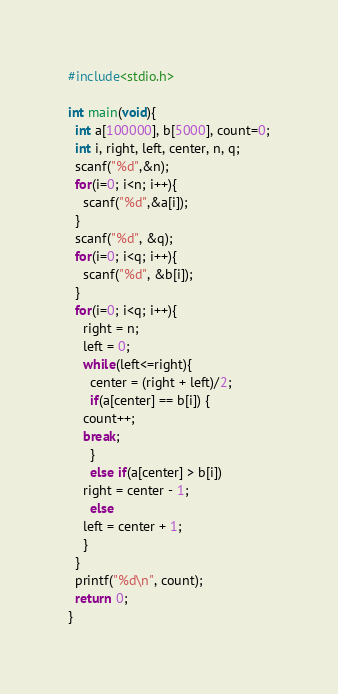<code> <loc_0><loc_0><loc_500><loc_500><_C_>#include<stdio.h>

int main(void){
  int a[100000], b[5000], count=0;
  int i, right, left, center, n, q;
  scanf("%d",&n);
  for(i=0; i<n; i++){
    scanf("%d",&a[i]);
  }
  scanf("%d", &q);
  for(i=0; i<q; i++){
    scanf("%d", &b[i]);
  }
  for(i=0; i<q; i++){
    right = n;
    left = 0; 
    while(left<=right){
      center = (right + left)/2;
      if(a[center] == b[i]) {
	count++;
	break;
      }
      else if(a[center] > b[i])
	right = center - 1;
      else
	left = center + 1;
    }
  }
  printf("%d\n", count);
  return 0;
}</code> 